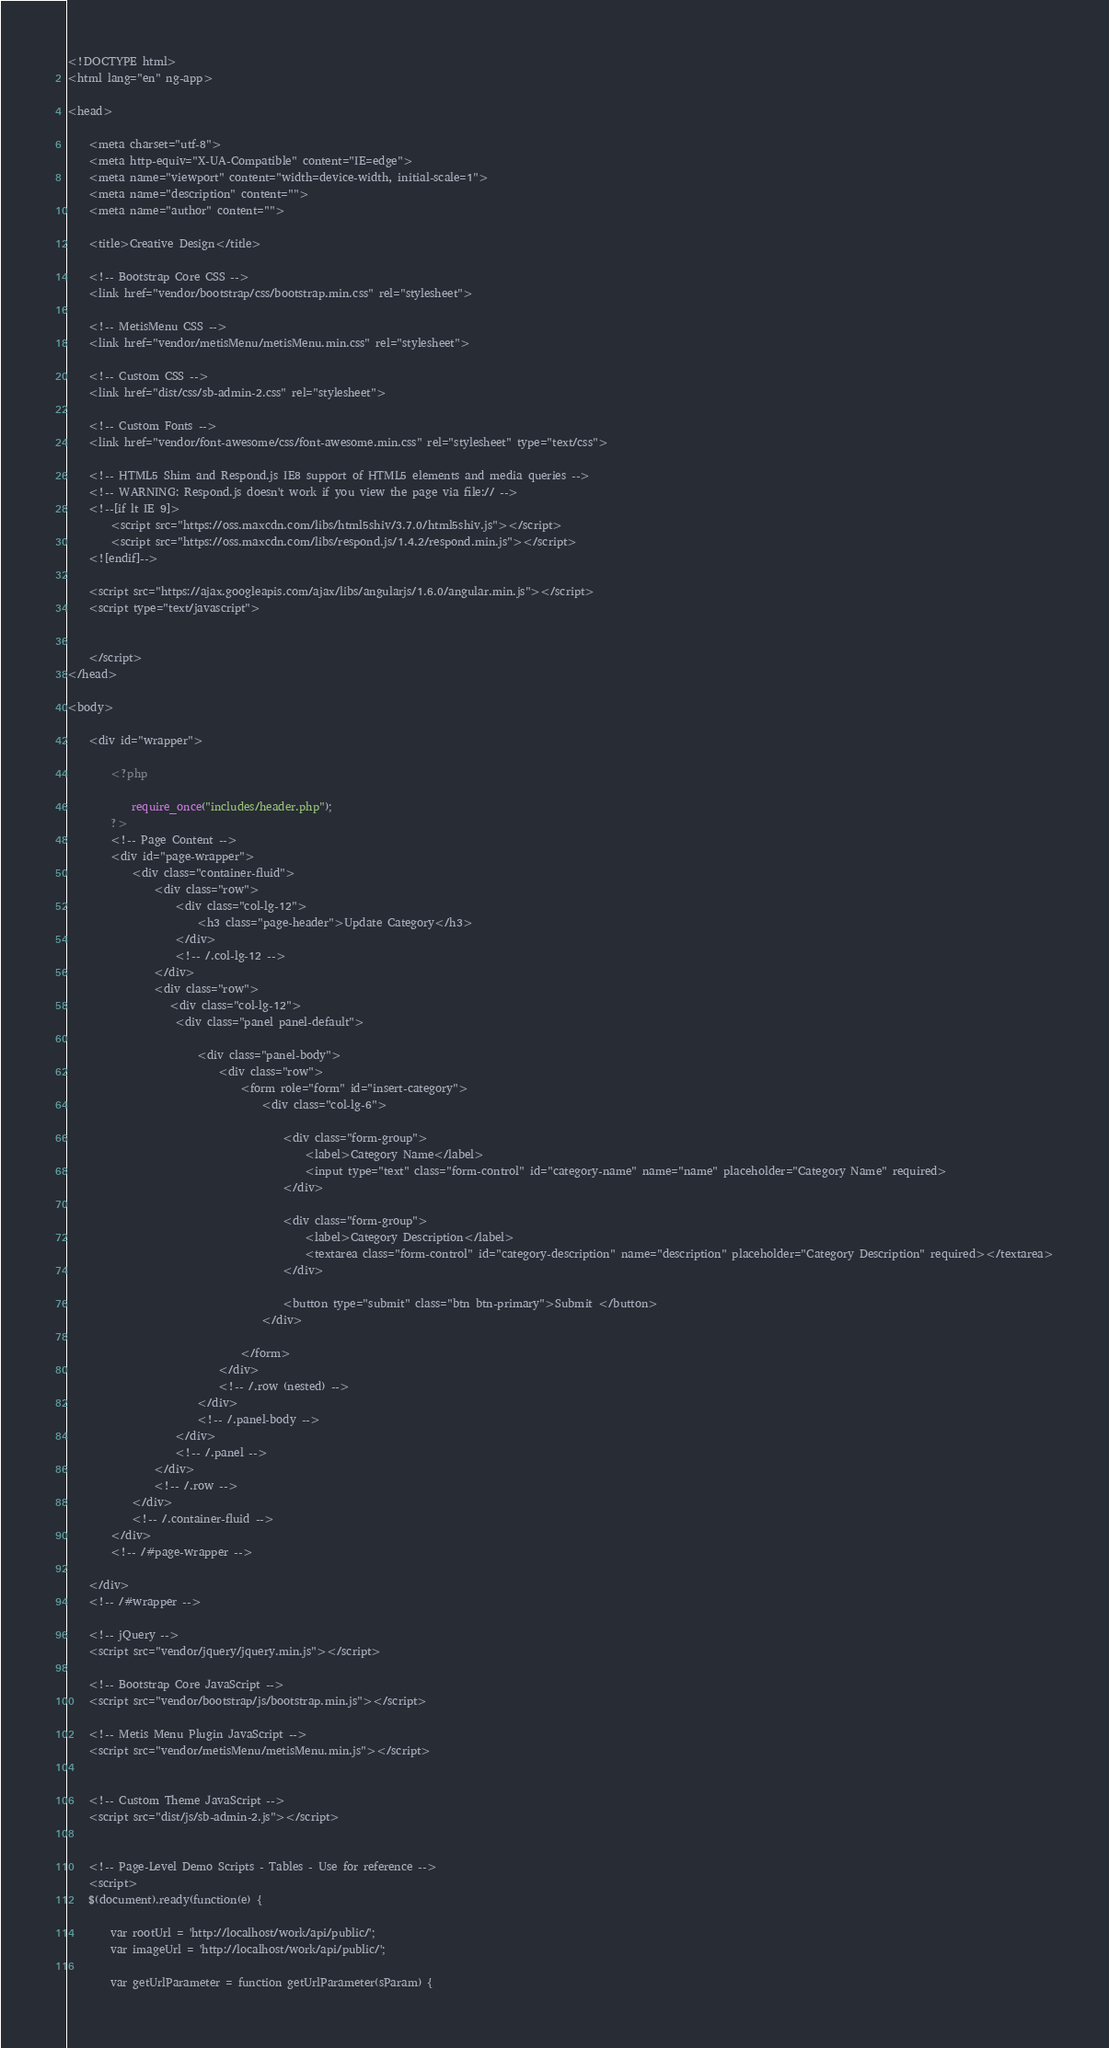Convert code to text. <code><loc_0><loc_0><loc_500><loc_500><_PHP_><!DOCTYPE html>
<html lang="en" ng-app>

<head>

    <meta charset="utf-8">
    <meta http-equiv="X-UA-Compatible" content="IE=edge">
    <meta name="viewport" content="width=device-width, initial-scale=1">
    <meta name="description" content="">
    <meta name="author" content="">

    <title>Creative Design</title>

    <!-- Bootstrap Core CSS -->
    <link href="vendor/bootstrap/css/bootstrap.min.css" rel="stylesheet">

    <!-- MetisMenu CSS -->
    <link href="vendor/metisMenu/metisMenu.min.css" rel="stylesheet">

    <!-- Custom CSS -->
    <link href="dist/css/sb-admin-2.css" rel="stylesheet">

    <!-- Custom Fonts -->
    <link href="vendor/font-awesome/css/font-awesome.min.css" rel="stylesheet" type="text/css">

    <!-- HTML5 Shim and Respond.js IE8 support of HTML5 elements and media queries -->
    <!-- WARNING: Respond.js doesn't work if you view the page via file:// -->
    <!--[if lt IE 9]>
        <script src="https://oss.maxcdn.com/libs/html5shiv/3.7.0/html5shiv.js"></script>
        <script src="https://oss.maxcdn.com/libs/respond.js/1.4.2/respond.min.js"></script>
    <![endif]-->

    <script src="https://ajax.googleapis.com/ajax/libs/angularjs/1.6.0/angular.min.js"></script>
    <script type="text/javascript">
        

    </script>
</head>

<body>

    <div id="wrapper">

        <?php 

            require_once("includes/header.php");
        ?>
        <!-- Page Content -->
        <div id="page-wrapper">
            <div class="container-fluid">
                <div class="row">
                    <div class="col-lg-12">
                        <h3 class="page-header">Update Category</h3>
                    </div>
                    <!-- /.col-lg-12 -->
                </div>
                <div class="row">
                   <div class="col-lg-12">
                    <div class="panel panel-default">
                       
                        <div class="panel-body">
                            <div class="row">
                                <form role="form" id="insert-category">
                                    <div class="col-lg-6">
                                        
                                        <div class="form-group">
                                            <label>Category Name</label>
                                            <input type="text" class="form-control" id="category-name" name="name" placeholder="Category Name" required>
                                        </div>

                                        <div class="form-group">
                                            <label>Category Description</label>
                                            <textarea class="form-control" id="category-description" name="description" placeholder="Category Description" required></textarea>
                                        </div>
                                       
                                        <button type="submit" class="btn btn-primary">Submit </button>
                                    </div>
                                    
                                </form>
                            </div>
                            <!-- /.row (nested) -->
                        </div>
                        <!-- /.panel-body -->
                    </div>
                    <!-- /.panel -->
                </div>
                <!-- /.row -->
            </div>
            <!-- /.container-fluid -->
        </div>
        <!-- /#page-wrapper -->

    </div>
    <!-- /#wrapper -->

    <!-- jQuery -->
    <script src="vendor/jquery/jquery.min.js"></script>

    <!-- Bootstrap Core JavaScript -->
    <script src="vendor/bootstrap/js/bootstrap.min.js"></script>

    <!-- Metis Menu Plugin JavaScript -->
    <script src="vendor/metisMenu/metisMenu.min.js"></script>


    <!-- Custom Theme JavaScript -->
    <script src="dist/js/sb-admin-2.js"></script>


    <!-- Page-Level Demo Scripts - Tables - Use for reference -->
    <script>
    $(document).ready(function(e) {
        
        var rootUrl = 'http://localhost/work/api/public/';
        var imageUrl = 'http://localhost/work/api/public/';

        var getUrlParameter = function getUrlParameter(sParam) {</code> 